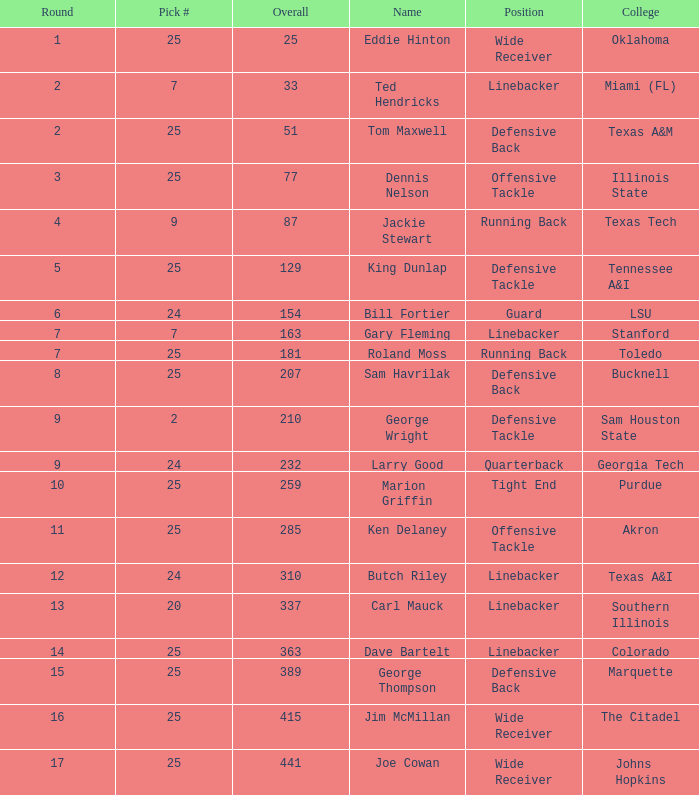Pick # of 25, and an Overall of 207 has what name? Sam Havrilak. 